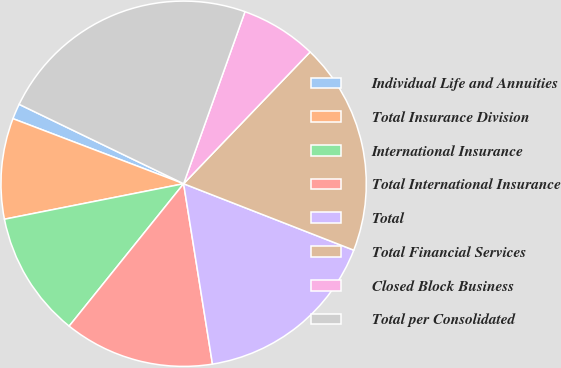Convert chart to OTSL. <chart><loc_0><loc_0><loc_500><loc_500><pie_chart><fcel>Individual Life and Annuities<fcel>Total Insurance Division<fcel>International Insurance<fcel>Total International Insurance<fcel>Total<fcel>Total Financial Services<fcel>Closed Block Business<fcel>Total per Consolidated<nl><fcel>1.36%<fcel>8.91%<fcel>11.11%<fcel>13.3%<fcel>16.55%<fcel>18.75%<fcel>6.72%<fcel>23.29%<nl></chart> 